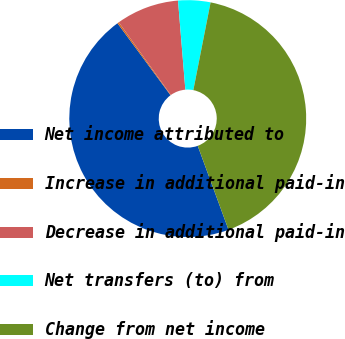Convert chart. <chart><loc_0><loc_0><loc_500><loc_500><pie_chart><fcel>Net income attributed to<fcel>Increase in additional paid-in<fcel>Decrease in additional paid-in<fcel>Net transfers (to) from<fcel>Change from net income<nl><fcel>45.49%<fcel>0.22%<fcel>8.58%<fcel>4.4%<fcel>41.31%<nl></chart> 